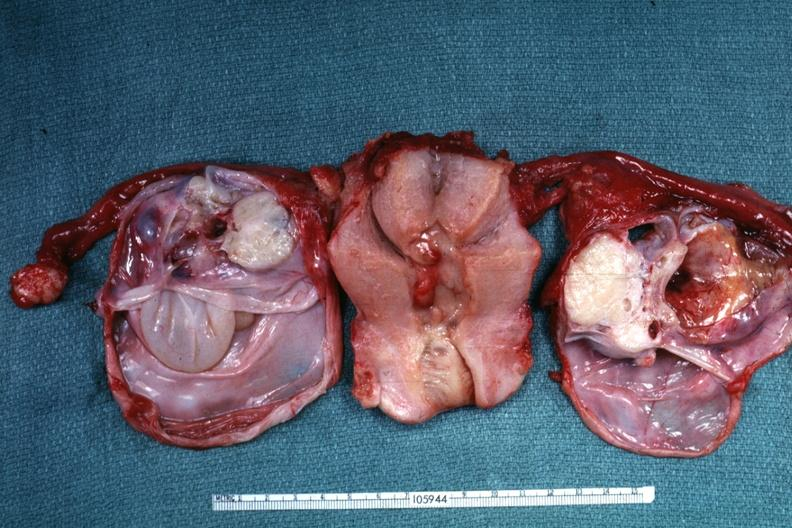what is present?
Answer the question using a single word or phrase. Female reproductive 